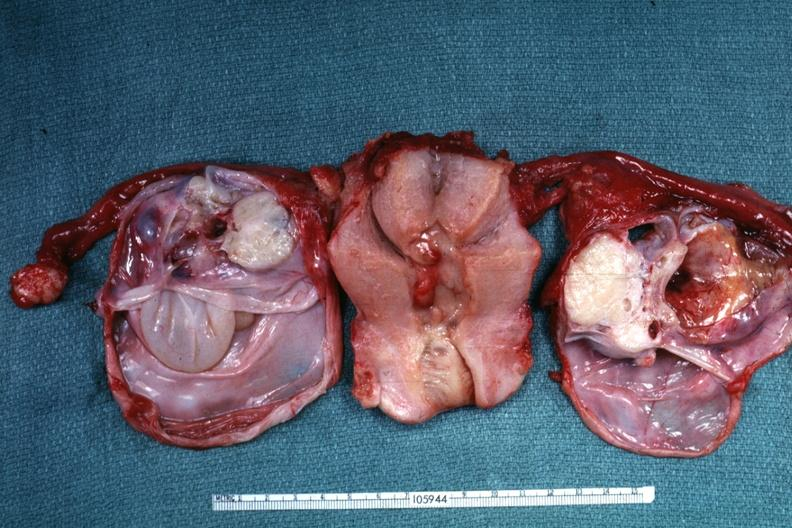what is present?
Answer the question using a single word or phrase. Female reproductive 